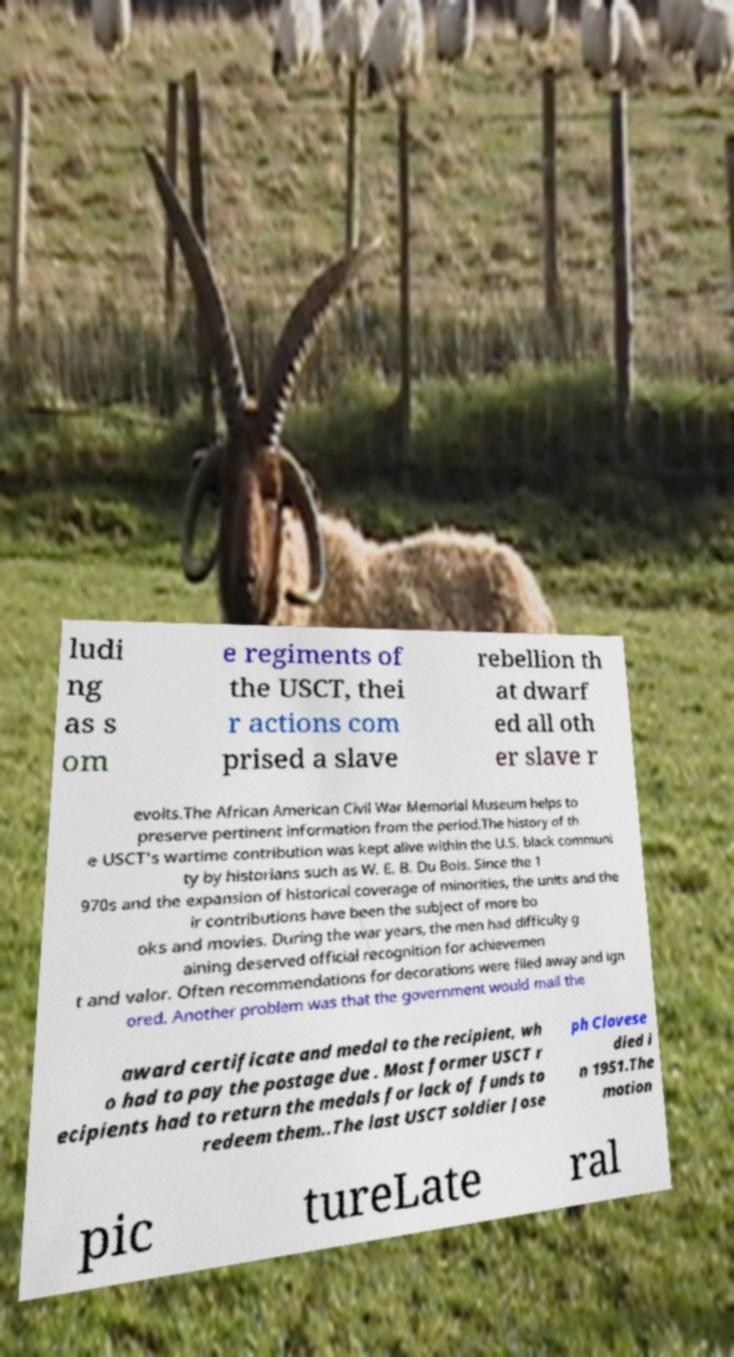For documentation purposes, I need the text within this image transcribed. Could you provide that? ludi ng as s om e regiments of the USCT, thei r actions com prised a slave rebellion th at dwarf ed all oth er slave r evolts.The African American Civil War Memorial Museum helps to preserve pertinent information from the period.The history of th e USCT's wartime contribution was kept alive within the U.S. black communi ty by historians such as W. E. B. Du Bois. Since the 1 970s and the expansion of historical coverage of minorities, the units and the ir contributions have been the subject of more bo oks and movies. During the war years, the men had difficulty g aining deserved official recognition for achievemen t and valor. Often recommendations for decorations were filed away and ign ored. Another problem was that the government would mail the award certificate and medal to the recipient, wh o had to pay the postage due . Most former USCT r ecipients had to return the medals for lack of funds to redeem them..The last USCT soldier Jose ph Clovese died i n 1951.The motion pic tureLate ral 